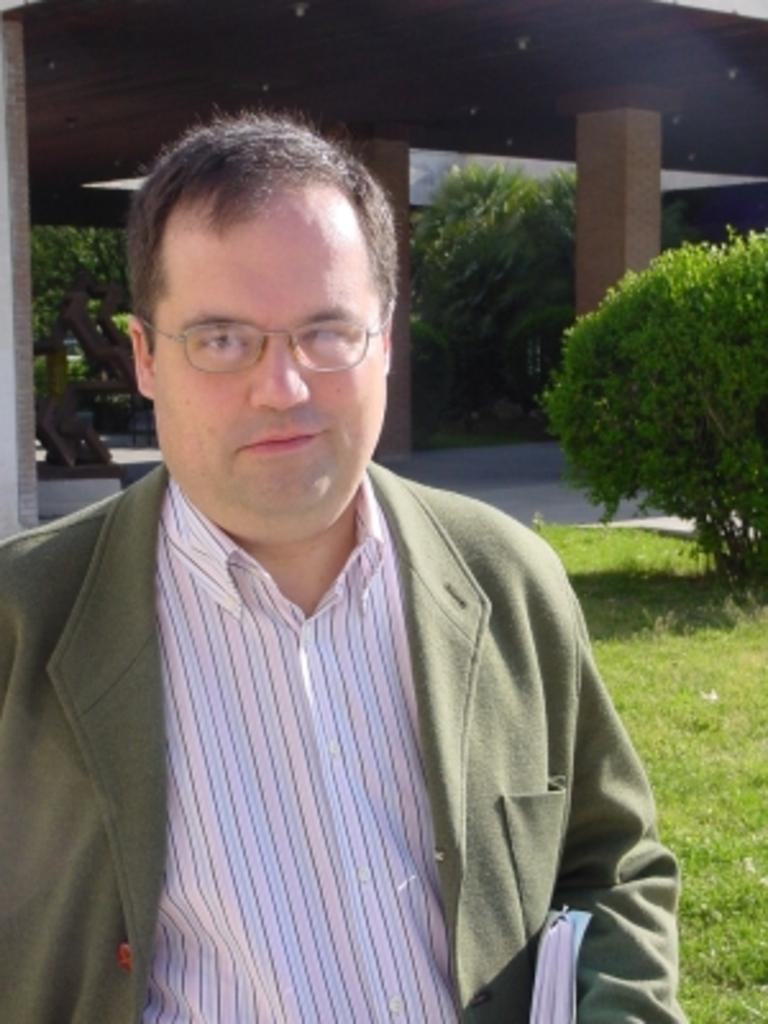Who is present in the image? There is a man in the picture. What is the man wearing? The man is wearing a blazer and spectacles. What is the man holding in the image? The man is holding a book. What can be seen in the background of the picture? There are trees, pillars, and grass in the background of the picture. What type of care is the man providing to the cobweb in the image? There is no mention of a cobweb in the image, and the man is not providing any care to any object in the image. 